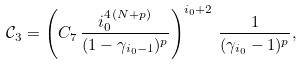Convert formula to latex. <formula><loc_0><loc_0><loc_500><loc_500>\mathcal { C } _ { 3 } = \left ( C _ { 7 } \, \frac { i _ { 0 } ^ { 4 \, ( N + p ) } } { ( 1 - \gamma _ { i _ { 0 } - 1 } ) ^ { p } } \right ) ^ { i _ { 0 } + 2 } \, \frac { 1 } { ( \gamma _ { i _ { 0 } } - 1 ) ^ { p } } ,</formula> 